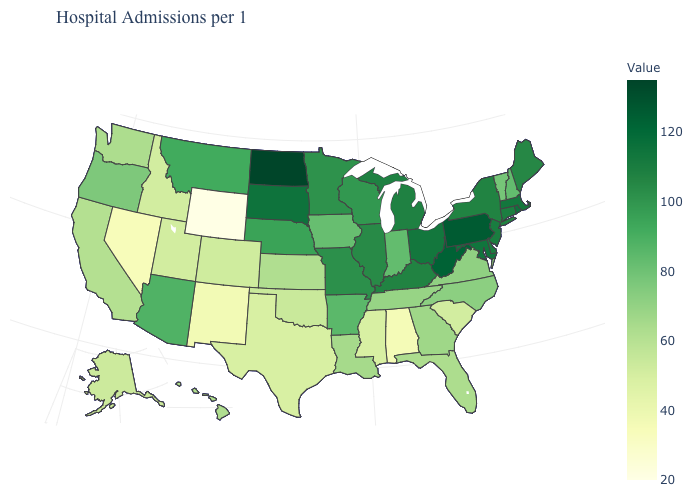Which states have the highest value in the USA?
Give a very brief answer. North Dakota. Which states have the lowest value in the USA?
Give a very brief answer. Wyoming. Does the map have missing data?
Quick response, please. No. Does Utah have a higher value than Alabama?
Keep it brief. Yes. Does the map have missing data?
Answer briefly. No. Which states have the highest value in the USA?
Answer briefly. North Dakota. Which states have the highest value in the USA?
Keep it brief. North Dakota. Does the map have missing data?
Keep it brief. No. 